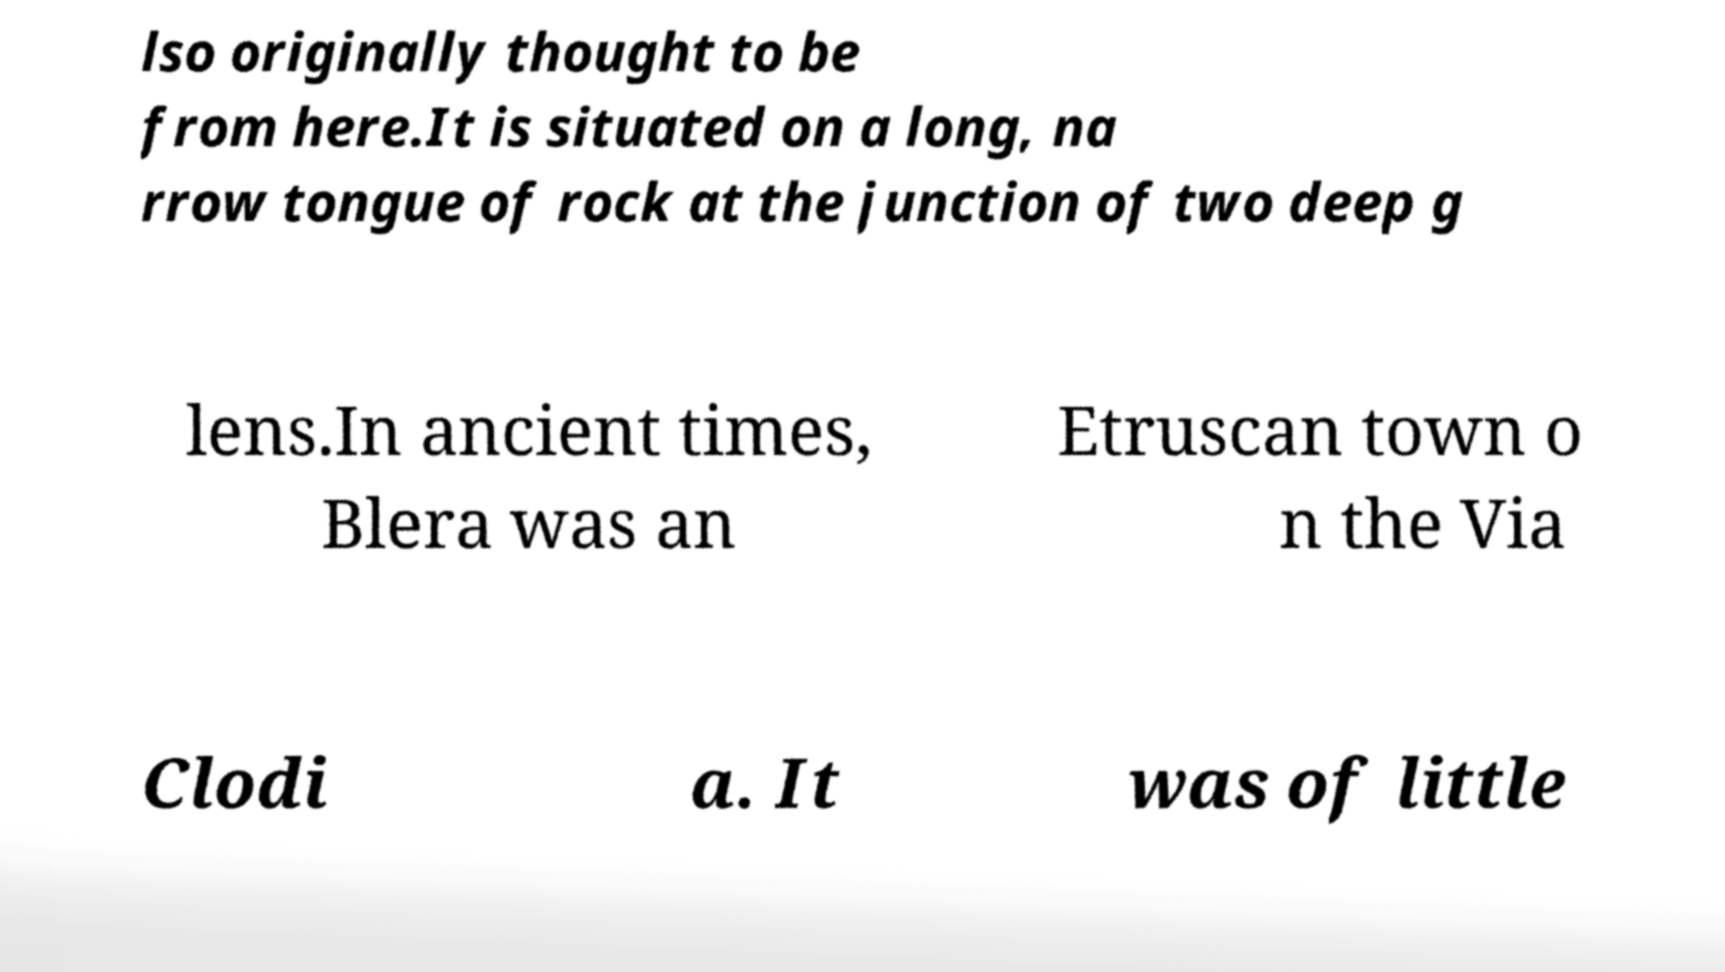Can you accurately transcribe the text from the provided image for me? lso originally thought to be from here.It is situated on a long, na rrow tongue of rock at the junction of two deep g lens.In ancient times, Blera was an Etruscan town o n the Via Clodi a. It was of little 